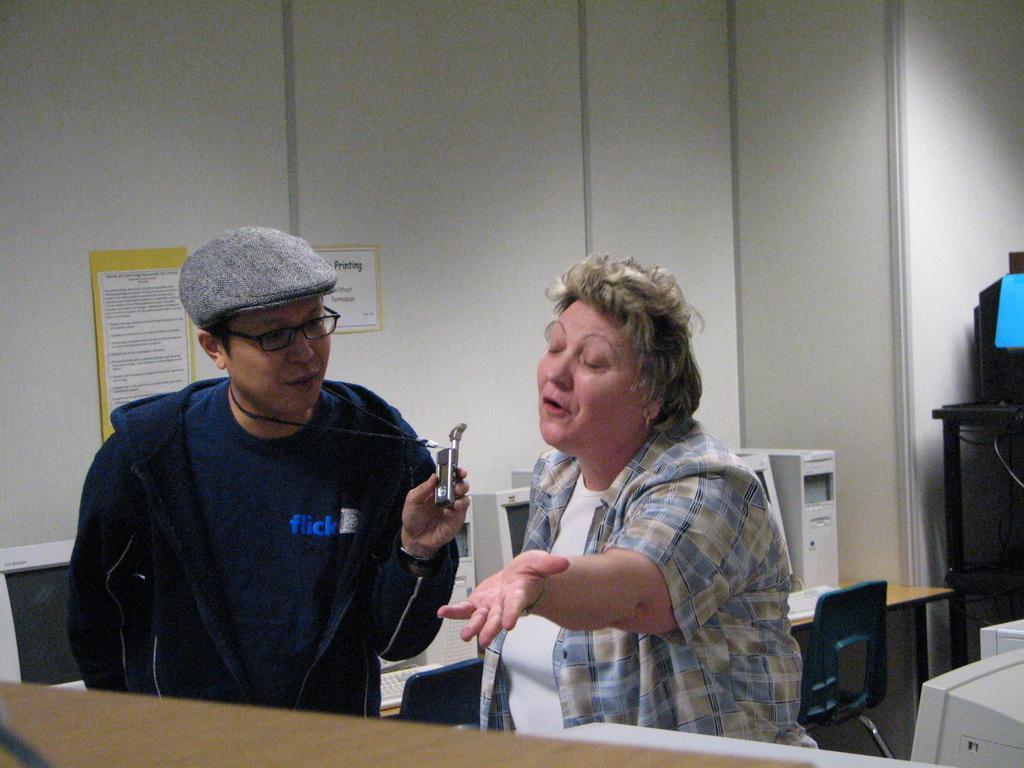How would you summarize this image in a sentence or two? In this image I can see a woman is talking, she wore shirt, beside her there is a man, he wore coat, cap, spectacles. It looks like an office. 